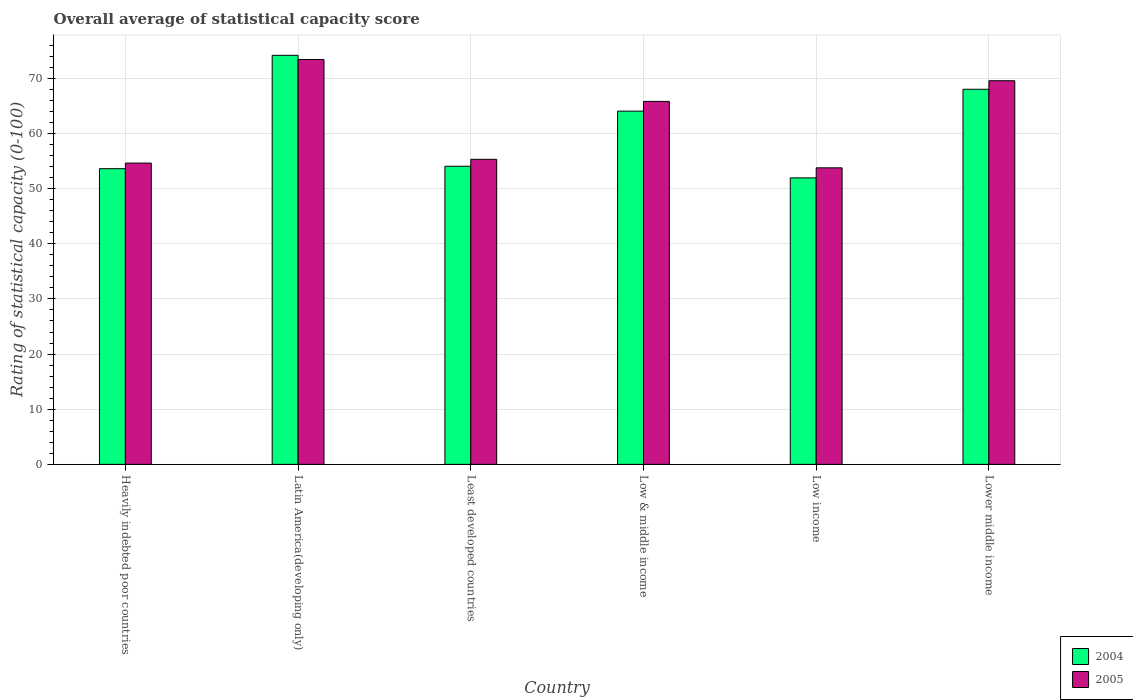How many groups of bars are there?
Your answer should be very brief. 6. Are the number of bars per tick equal to the number of legend labels?
Your answer should be very brief. Yes. What is the label of the 2nd group of bars from the left?
Your response must be concise. Latin America(developing only). What is the rating of statistical capacity in 2005 in Latin America(developing only)?
Keep it short and to the point. 73.4. Across all countries, what is the maximum rating of statistical capacity in 2004?
Provide a short and direct response. 74.17. Across all countries, what is the minimum rating of statistical capacity in 2005?
Keep it short and to the point. 53.77. In which country was the rating of statistical capacity in 2005 maximum?
Offer a very short reply. Latin America(developing only). In which country was the rating of statistical capacity in 2005 minimum?
Provide a succinct answer. Low income. What is the total rating of statistical capacity in 2005 in the graph?
Give a very brief answer. 372.49. What is the difference between the rating of statistical capacity in 2005 in Heavily indebted poor countries and that in Low income?
Your response must be concise. 0.86. What is the difference between the rating of statistical capacity in 2004 in Latin America(developing only) and the rating of statistical capacity in 2005 in Lower middle income?
Give a very brief answer. 4.61. What is the average rating of statistical capacity in 2004 per country?
Offer a terse response. 60.97. What is the difference between the rating of statistical capacity of/in 2005 and rating of statistical capacity of/in 2004 in Heavily indebted poor countries?
Give a very brief answer. 1.02. What is the ratio of the rating of statistical capacity in 2005 in Least developed countries to that in Low & middle income?
Offer a terse response. 0.84. Is the difference between the rating of statistical capacity in 2005 in Heavily indebted poor countries and Low income greater than the difference between the rating of statistical capacity in 2004 in Heavily indebted poor countries and Low income?
Provide a short and direct response. No. What is the difference between the highest and the second highest rating of statistical capacity in 2005?
Your response must be concise. -7.59. What is the difference between the highest and the lowest rating of statistical capacity in 2004?
Ensure brevity in your answer.  22.22. How many bars are there?
Give a very brief answer. 12. Are all the bars in the graph horizontal?
Provide a succinct answer. No. How many countries are there in the graph?
Offer a very short reply. 6. What is the difference between two consecutive major ticks on the Y-axis?
Ensure brevity in your answer.  10. Where does the legend appear in the graph?
Offer a terse response. Bottom right. How many legend labels are there?
Your response must be concise. 2. How are the legend labels stacked?
Your response must be concise. Vertical. What is the title of the graph?
Keep it short and to the point. Overall average of statistical capacity score. Does "2008" appear as one of the legend labels in the graph?
Your answer should be compact. No. What is the label or title of the Y-axis?
Offer a terse response. Rating of statistical capacity (0-100). What is the Rating of statistical capacity (0-100) in 2004 in Heavily indebted poor countries?
Your answer should be compact. 53.61. What is the Rating of statistical capacity (0-100) in 2005 in Heavily indebted poor countries?
Your answer should be compact. 54.63. What is the Rating of statistical capacity (0-100) of 2004 in Latin America(developing only)?
Keep it short and to the point. 74.17. What is the Rating of statistical capacity (0-100) of 2005 in Latin America(developing only)?
Provide a succinct answer. 73.4. What is the Rating of statistical capacity (0-100) of 2004 in Least developed countries?
Give a very brief answer. 54.05. What is the Rating of statistical capacity (0-100) in 2005 in Least developed countries?
Provide a succinct answer. 55.32. What is the Rating of statistical capacity (0-100) in 2004 in Low & middle income?
Give a very brief answer. 64.05. What is the Rating of statistical capacity (0-100) in 2005 in Low & middle income?
Your answer should be very brief. 65.81. What is the Rating of statistical capacity (0-100) of 2004 in Low income?
Ensure brevity in your answer.  51.94. What is the Rating of statistical capacity (0-100) in 2005 in Low income?
Offer a very short reply. 53.77. What is the Rating of statistical capacity (0-100) of 2004 in Lower middle income?
Provide a succinct answer. 68.01. What is the Rating of statistical capacity (0-100) in 2005 in Lower middle income?
Provide a succinct answer. 69.56. Across all countries, what is the maximum Rating of statistical capacity (0-100) in 2004?
Give a very brief answer. 74.17. Across all countries, what is the maximum Rating of statistical capacity (0-100) of 2005?
Provide a succinct answer. 73.4. Across all countries, what is the minimum Rating of statistical capacity (0-100) in 2004?
Keep it short and to the point. 51.94. Across all countries, what is the minimum Rating of statistical capacity (0-100) in 2005?
Ensure brevity in your answer.  53.77. What is the total Rating of statistical capacity (0-100) of 2004 in the graph?
Provide a succinct answer. 365.84. What is the total Rating of statistical capacity (0-100) of 2005 in the graph?
Provide a short and direct response. 372.49. What is the difference between the Rating of statistical capacity (0-100) in 2004 in Heavily indebted poor countries and that in Latin America(developing only)?
Provide a short and direct response. -20.56. What is the difference between the Rating of statistical capacity (0-100) in 2005 in Heavily indebted poor countries and that in Latin America(developing only)?
Provide a short and direct response. -18.77. What is the difference between the Rating of statistical capacity (0-100) in 2004 in Heavily indebted poor countries and that in Least developed countries?
Your answer should be very brief. -0.44. What is the difference between the Rating of statistical capacity (0-100) of 2005 in Heavily indebted poor countries and that in Least developed countries?
Provide a short and direct response. -0.69. What is the difference between the Rating of statistical capacity (0-100) in 2004 in Heavily indebted poor countries and that in Low & middle income?
Provide a succinct answer. -10.44. What is the difference between the Rating of statistical capacity (0-100) in 2005 in Heavily indebted poor countries and that in Low & middle income?
Make the answer very short. -11.18. What is the difference between the Rating of statistical capacity (0-100) in 2005 in Heavily indebted poor countries and that in Low income?
Make the answer very short. 0.86. What is the difference between the Rating of statistical capacity (0-100) of 2004 in Heavily indebted poor countries and that in Lower middle income?
Your answer should be very brief. -14.4. What is the difference between the Rating of statistical capacity (0-100) in 2005 in Heavily indebted poor countries and that in Lower middle income?
Keep it short and to the point. -14.93. What is the difference between the Rating of statistical capacity (0-100) of 2004 in Latin America(developing only) and that in Least developed countries?
Your answer should be compact. 20.11. What is the difference between the Rating of statistical capacity (0-100) of 2005 in Latin America(developing only) and that in Least developed countries?
Provide a short and direct response. 18.09. What is the difference between the Rating of statistical capacity (0-100) of 2004 in Latin America(developing only) and that in Low & middle income?
Offer a terse response. 10.12. What is the difference between the Rating of statistical capacity (0-100) in 2005 in Latin America(developing only) and that in Low & middle income?
Ensure brevity in your answer.  7.59. What is the difference between the Rating of statistical capacity (0-100) in 2004 in Latin America(developing only) and that in Low income?
Give a very brief answer. 22.22. What is the difference between the Rating of statistical capacity (0-100) in 2005 in Latin America(developing only) and that in Low income?
Provide a succinct answer. 19.63. What is the difference between the Rating of statistical capacity (0-100) of 2004 in Latin America(developing only) and that in Lower middle income?
Your response must be concise. 6.16. What is the difference between the Rating of statistical capacity (0-100) of 2005 in Latin America(developing only) and that in Lower middle income?
Keep it short and to the point. 3.84. What is the difference between the Rating of statistical capacity (0-100) in 2004 in Least developed countries and that in Low & middle income?
Your answer should be very brief. -10. What is the difference between the Rating of statistical capacity (0-100) of 2005 in Least developed countries and that in Low & middle income?
Your answer should be very brief. -10.5. What is the difference between the Rating of statistical capacity (0-100) in 2004 in Least developed countries and that in Low income?
Your response must be concise. 2.11. What is the difference between the Rating of statistical capacity (0-100) in 2005 in Least developed countries and that in Low income?
Offer a very short reply. 1.55. What is the difference between the Rating of statistical capacity (0-100) in 2004 in Least developed countries and that in Lower middle income?
Offer a terse response. -13.96. What is the difference between the Rating of statistical capacity (0-100) of 2005 in Least developed countries and that in Lower middle income?
Your answer should be very brief. -14.25. What is the difference between the Rating of statistical capacity (0-100) of 2004 in Low & middle income and that in Low income?
Provide a short and direct response. 12.1. What is the difference between the Rating of statistical capacity (0-100) in 2005 in Low & middle income and that in Low income?
Offer a terse response. 12.04. What is the difference between the Rating of statistical capacity (0-100) of 2004 in Low & middle income and that in Lower middle income?
Your answer should be compact. -3.96. What is the difference between the Rating of statistical capacity (0-100) in 2005 in Low & middle income and that in Lower middle income?
Give a very brief answer. -3.75. What is the difference between the Rating of statistical capacity (0-100) in 2004 in Low income and that in Lower middle income?
Offer a very short reply. -16.07. What is the difference between the Rating of statistical capacity (0-100) of 2005 in Low income and that in Lower middle income?
Give a very brief answer. -15.79. What is the difference between the Rating of statistical capacity (0-100) in 2004 in Heavily indebted poor countries and the Rating of statistical capacity (0-100) in 2005 in Latin America(developing only)?
Make the answer very short. -19.79. What is the difference between the Rating of statistical capacity (0-100) in 2004 in Heavily indebted poor countries and the Rating of statistical capacity (0-100) in 2005 in Least developed countries?
Your response must be concise. -1.7. What is the difference between the Rating of statistical capacity (0-100) of 2004 in Heavily indebted poor countries and the Rating of statistical capacity (0-100) of 2005 in Low & middle income?
Offer a very short reply. -12.2. What is the difference between the Rating of statistical capacity (0-100) of 2004 in Heavily indebted poor countries and the Rating of statistical capacity (0-100) of 2005 in Low income?
Provide a succinct answer. -0.16. What is the difference between the Rating of statistical capacity (0-100) of 2004 in Heavily indebted poor countries and the Rating of statistical capacity (0-100) of 2005 in Lower middle income?
Make the answer very short. -15.95. What is the difference between the Rating of statistical capacity (0-100) of 2004 in Latin America(developing only) and the Rating of statistical capacity (0-100) of 2005 in Least developed countries?
Provide a succinct answer. 18.85. What is the difference between the Rating of statistical capacity (0-100) of 2004 in Latin America(developing only) and the Rating of statistical capacity (0-100) of 2005 in Low & middle income?
Offer a terse response. 8.35. What is the difference between the Rating of statistical capacity (0-100) in 2004 in Latin America(developing only) and the Rating of statistical capacity (0-100) in 2005 in Low income?
Your answer should be compact. 20.4. What is the difference between the Rating of statistical capacity (0-100) of 2004 in Latin America(developing only) and the Rating of statistical capacity (0-100) of 2005 in Lower middle income?
Your response must be concise. 4.61. What is the difference between the Rating of statistical capacity (0-100) in 2004 in Least developed countries and the Rating of statistical capacity (0-100) in 2005 in Low & middle income?
Keep it short and to the point. -11.76. What is the difference between the Rating of statistical capacity (0-100) of 2004 in Least developed countries and the Rating of statistical capacity (0-100) of 2005 in Low income?
Your response must be concise. 0.28. What is the difference between the Rating of statistical capacity (0-100) of 2004 in Least developed countries and the Rating of statistical capacity (0-100) of 2005 in Lower middle income?
Your answer should be compact. -15.51. What is the difference between the Rating of statistical capacity (0-100) in 2004 in Low & middle income and the Rating of statistical capacity (0-100) in 2005 in Low income?
Offer a very short reply. 10.28. What is the difference between the Rating of statistical capacity (0-100) in 2004 in Low & middle income and the Rating of statistical capacity (0-100) in 2005 in Lower middle income?
Provide a short and direct response. -5.51. What is the difference between the Rating of statistical capacity (0-100) in 2004 in Low income and the Rating of statistical capacity (0-100) in 2005 in Lower middle income?
Your answer should be compact. -17.62. What is the average Rating of statistical capacity (0-100) in 2004 per country?
Provide a succinct answer. 60.97. What is the average Rating of statistical capacity (0-100) of 2005 per country?
Provide a succinct answer. 62.08. What is the difference between the Rating of statistical capacity (0-100) in 2004 and Rating of statistical capacity (0-100) in 2005 in Heavily indebted poor countries?
Your response must be concise. -1.02. What is the difference between the Rating of statistical capacity (0-100) of 2004 and Rating of statistical capacity (0-100) of 2005 in Latin America(developing only)?
Ensure brevity in your answer.  0.76. What is the difference between the Rating of statistical capacity (0-100) in 2004 and Rating of statistical capacity (0-100) in 2005 in Least developed countries?
Provide a succinct answer. -1.26. What is the difference between the Rating of statistical capacity (0-100) of 2004 and Rating of statistical capacity (0-100) of 2005 in Low & middle income?
Provide a succinct answer. -1.76. What is the difference between the Rating of statistical capacity (0-100) of 2004 and Rating of statistical capacity (0-100) of 2005 in Low income?
Give a very brief answer. -1.83. What is the difference between the Rating of statistical capacity (0-100) in 2004 and Rating of statistical capacity (0-100) in 2005 in Lower middle income?
Your answer should be very brief. -1.55. What is the ratio of the Rating of statistical capacity (0-100) in 2004 in Heavily indebted poor countries to that in Latin America(developing only)?
Keep it short and to the point. 0.72. What is the ratio of the Rating of statistical capacity (0-100) in 2005 in Heavily indebted poor countries to that in Latin America(developing only)?
Provide a succinct answer. 0.74. What is the ratio of the Rating of statistical capacity (0-100) of 2004 in Heavily indebted poor countries to that in Least developed countries?
Ensure brevity in your answer.  0.99. What is the ratio of the Rating of statistical capacity (0-100) in 2005 in Heavily indebted poor countries to that in Least developed countries?
Offer a very short reply. 0.99. What is the ratio of the Rating of statistical capacity (0-100) of 2004 in Heavily indebted poor countries to that in Low & middle income?
Your response must be concise. 0.84. What is the ratio of the Rating of statistical capacity (0-100) of 2005 in Heavily indebted poor countries to that in Low & middle income?
Make the answer very short. 0.83. What is the ratio of the Rating of statistical capacity (0-100) in 2004 in Heavily indebted poor countries to that in Low income?
Provide a succinct answer. 1.03. What is the ratio of the Rating of statistical capacity (0-100) of 2005 in Heavily indebted poor countries to that in Low income?
Offer a terse response. 1.02. What is the ratio of the Rating of statistical capacity (0-100) of 2004 in Heavily indebted poor countries to that in Lower middle income?
Your answer should be very brief. 0.79. What is the ratio of the Rating of statistical capacity (0-100) of 2005 in Heavily indebted poor countries to that in Lower middle income?
Make the answer very short. 0.79. What is the ratio of the Rating of statistical capacity (0-100) in 2004 in Latin America(developing only) to that in Least developed countries?
Your answer should be very brief. 1.37. What is the ratio of the Rating of statistical capacity (0-100) in 2005 in Latin America(developing only) to that in Least developed countries?
Your answer should be compact. 1.33. What is the ratio of the Rating of statistical capacity (0-100) of 2004 in Latin America(developing only) to that in Low & middle income?
Offer a terse response. 1.16. What is the ratio of the Rating of statistical capacity (0-100) of 2005 in Latin America(developing only) to that in Low & middle income?
Provide a succinct answer. 1.12. What is the ratio of the Rating of statistical capacity (0-100) of 2004 in Latin America(developing only) to that in Low income?
Provide a succinct answer. 1.43. What is the ratio of the Rating of statistical capacity (0-100) of 2005 in Latin America(developing only) to that in Low income?
Ensure brevity in your answer.  1.37. What is the ratio of the Rating of statistical capacity (0-100) in 2004 in Latin America(developing only) to that in Lower middle income?
Your response must be concise. 1.09. What is the ratio of the Rating of statistical capacity (0-100) of 2005 in Latin America(developing only) to that in Lower middle income?
Your answer should be compact. 1.06. What is the ratio of the Rating of statistical capacity (0-100) in 2004 in Least developed countries to that in Low & middle income?
Offer a very short reply. 0.84. What is the ratio of the Rating of statistical capacity (0-100) of 2005 in Least developed countries to that in Low & middle income?
Provide a succinct answer. 0.84. What is the ratio of the Rating of statistical capacity (0-100) in 2004 in Least developed countries to that in Low income?
Provide a short and direct response. 1.04. What is the ratio of the Rating of statistical capacity (0-100) of 2005 in Least developed countries to that in Low income?
Provide a short and direct response. 1.03. What is the ratio of the Rating of statistical capacity (0-100) of 2004 in Least developed countries to that in Lower middle income?
Keep it short and to the point. 0.79. What is the ratio of the Rating of statistical capacity (0-100) in 2005 in Least developed countries to that in Lower middle income?
Your answer should be very brief. 0.8. What is the ratio of the Rating of statistical capacity (0-100) in 2004 in Low & middle income to that in Low income?
Your response must be concise. 1.23. What is the ratio of the Rating of statistical capacity (0-100) in 2005 in Low & middle income to that in Low income?
Provide a succinct answer. 1.22. What is the ratio of the Rating of statistical capacity (0-100) of 2004 in Low & middle income to that in Lower middle income?
Keep it short and to the point. 0.94. What is the ratio of the Rating of statistical capacity (0-100) in 2005 in Low & middle income to that in Lower middle income?
Offer a terse response. 0.95. What is the ratio of the Rating of statistical capacity (0-100) in 2004 in Low income to that in Lower middle income?
Give a very brief answer. 0.76. What is the ratio of the Rating of statistical capacity (0-100) in 2005 in Low income to that in Lower middle income?
Your response must be concise. 0.77. What is the difference between the highest and the second highest Rating of statistical capacity (0-100) in 2004?
Your answer should be compact. 6.16. What is the difference between the highest and the second highest Rating of statistical capacity (0-100) in 2005?
Offer a terse response. 3.84. What is the difference between the highest and the lowest Rating of statistical capacity (0-100) of 2004?
Ensure brevity in your answer.  22.22. What is the difference between the highest and the lowest Rating of statistical capacity (0-100) of 2005?
Offer a terse response. 19.63. 